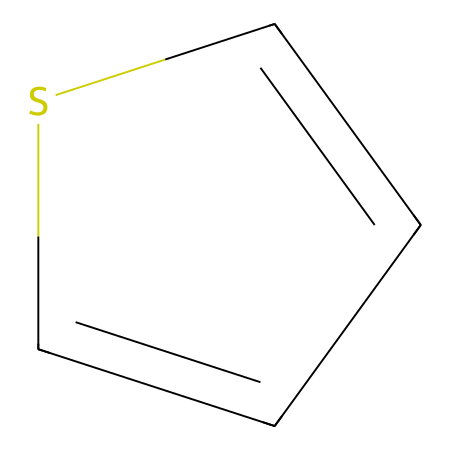What is the core structure of this chemical? The chemical presented has a five-membered ring structure that consists of a sulfur atom and four carbon atoms, indicating it is a thiophene derivative.
Answer: thiophene How many carbon atoms are present in this compound? By analyzing the SMILES representation, we can count the carbon atoms; there are four carbon atoms in the ring structure.
Answer: four What type of bonding is primarily present in this compound? The compound features a series of conjugated double bonds in the aromatic ring, which allows for the delocalization of electrons, characteristic of aromatic compounds.
Answer: aromatic What is the function of the sulfur atom in this compound? The sulfur atom in the ring contributes to the electronic properties of the compound, including its conductivity and potential doping characteristics due to its ability to participate in π-bonding.
Answer: conductivity What are the potential applications of the compound represented? Given its organic nature and conductive properties, this compound is often used in organic electronics, such as organic light-emitting diodes (OLEDs) and organic solar cells.
Answer: organic electronics Is this compound polar or nonpolar? Based on the structure, the presence of the sulfur atom and the carbon framework suggests it retains some polar characteristics, although it may act generally as nonpolar due to its overall symmetry.
Answer: nonpolar 